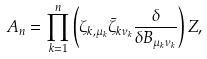<formula> <loc_0><loc_0><loc_500><loc_500>A _ { n } = \prod _ { k = 1 } ^ { n } \left ( \zeta _ { k , \mu _ { k } } \bar { \zeta } _ { k \nu _ { k } } { \frac { \delta } { \delta B _ { \mu _ { k } \nu _ { k } } } } \right ) Z ,</formula> 